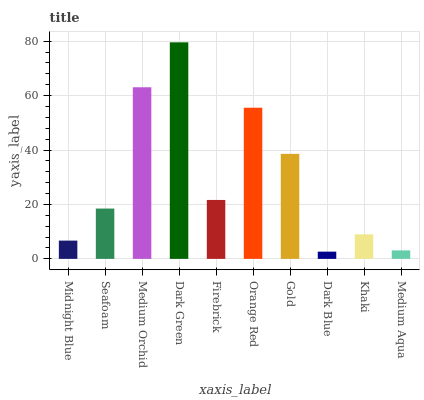Is Seafoam the minimum?
Answer yes or no. No. Is Seafoam the maximum?
Answer yes or no. No. Is Seafoam greater than Midnight Blue?
Answer yes or no. Yes. Is Midnight Blue less than Seafoam?
Answer yes or no. Yes. Is Midnight Blue greater than Seafoam?
Answer yes or no. No. Is Seafoam less than Midnight Blue?
Answer yes or no. No. Is Firebrick the high median?
Answer yes or no. Yes. Is Seafoam the low median?
Answer yes or no. Yes. Is Dark Green the high median?
Answer yes or no. No. Is Gold the low median?
Answer yes or no. No. 